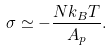Convert formula to latex. <formula><loc_0><loc_0><loc_500><loc_500>\sigma \simeq - \frac { N k _ { B } T } { A _ { p } } .</formula> 